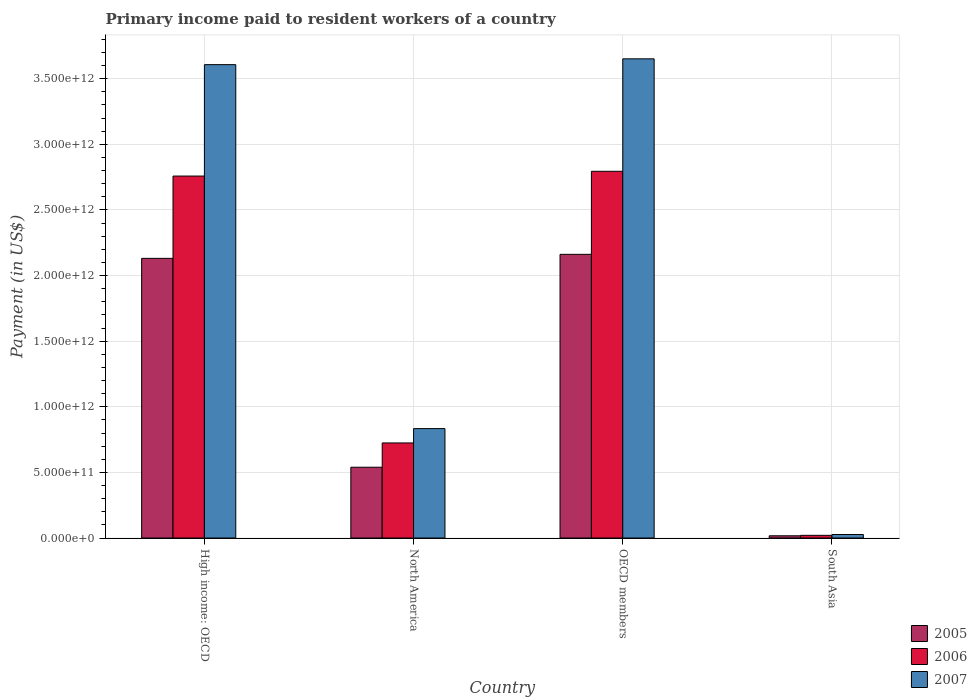How many groups of bars are there?
Your answer should be very brief. 4. Are the number of bars per tick equal to the number of legend labels?
Your answer should be very brief. Yes. How many bars are there on the 1st tick from the right?
Provide a short and direct response. 3. What is the label of the 4th group of bars from the left?
Your answer should be very brief. South Asia. In how many cases, is the number of bars for a given country not equal to the number of legend labels?
Your answer should be very brief. 0. What is the amount paid to workers in 2005 in OECD members?
Offer a very short reply. 2.16e+12. Across all countries, what is the maximum amount paid to workers in 2006?
Offer a very short reply. 2.79e+12. Across all countries, what is the minimum amount paid to workers in 2005?
Provide a short and direct response. 1.69e+1. In which country was the amount paid to workers in 2006 minimum?
Your response must be concise. South Asia. What is the total amount paid to workers in 2007 in the graph?
Offer a terse response. 8.12e+12. What is the difference between the amount paid to workers in 2005 in OECD members and that in South Asia?
Offer a terse response. 2.15e+12. What is the difference between the amount paid to workers in 2005 in OECD members and the amount paid to workers in 2007 in South Asia?
Offer a very short reply. 2.14e+12. What is the average amount paid to workers in 2007 per country?
Your response must be concise. 2.03e+12. What is the difference between the amount paid to workers of/in 2006 and amount paid to workers of/in 2005 in OECD members?
Give a very brief answer. 6.33e+11. In how many countries, is the amount paid to workers in 2006 greater than 1100000000000 US$?
Provide a short and direct response. 2. What is the ratio of the amount paid to workers in 2005 in North America to that in OECD members?
Provide a short and direct response. 0.25. Is the amount paid to workers in 2005 in High income: OECD less than that in OECD members?
Ensure brevity in your answer.  Yes. What is the difference between the highest and the second highest amount paid to workers in 2007?
Offer a terse response. 4.43e+1. What is the difference between the highest and the lowest amount paid to workers in 2006?
Provide a succinct answer. 2.77e+12. In how many countries, is the amount paid to workers in 2005 greater than the average amount paid to workers in 2005 taken over all countries?
Offer a terse response. 2. What does the 2nd bar from the left in South Asia represents?
Offer a terse response. 2006. Are all the bars in the graph horizontal?
Provide a short and direct response. No. How many countries are there in the graph?
Provide a succinct answer. 4. What is the difference between two consecutive major ticks on the Y-axis?
Give a very brief answer. 5.00e+11. Are the values on the major ticks of Y-axis written in scientific E-notation?
Provide a short and direct response. Yes. Does the graph contain any zero values?
Ensure brevity in your answer.  No. Where does the legend appear in the graph?
Make the answer very short. Bottom right. How are the legend labels stacked?
Offer a very short reply. Vertical. What is the title of the graph?
Keep it short and to the point. Primary income paid to resident workers of a country. What is the label or title of the Y-axis?
Keep it short and to the point. Payment (in US$). What is the Payment (in US$) in 2005 in High income: OECD?
Give a very brief answer. 2.13e+12. What is the Payment (in US$) in 2006 in High income: OECD?
Offer a very short reply. 2.76e+12. What is the Payment (in US$) of 2007 in High income: OECD?
Give a very brief answer. 3.61e+12. What is the Payment (in US$) of 2005 in North America?
Ensure brevity in your answer.  5.39e+11. What is the Payment (in US$) in 2006 in North America?
Your answer should be very brief. 7.24e+11. What is the Payment (in US$) in 2007 in North America?
Provide a short and direct response. 8.34e+11. What is the Payment (in US$) of 2005 in OECD members?
Your answer should be compact. 2.16e+12. What is the Payment (in US$) in 2006 in OECD members?
Your answer should be compact. 2.79e+12. What is the Payment (in US$) in 2007 in OECD members?
Provide a succinct answer. 3.65e+12. What is the Payment (in US$) in 2005 in South Asia?
Offer a very short reply. 1.69e+1. What is the Payment (in US$) in 2006 in South Asia?
Provide a succinct answer. 2.04e+1. What is the Payment (in US$) of 2007 in South Asia?
Your answer should be very brief. 2.66e+1. Across all countries, what is the maximum Payment (in US$) of 2005?
Make the answer very short. 2.16e+12. Across all countries, what is the maximum Payment (in US$) in 2006?
Give a very brief answer. 2.79e+12. Across all countries, what is the maximum Payment (in US$) of 2007?
Provide a succinct answer. 3.65e+12. Across all countries, what is the minimum Payment (in US$) of 2005?
Keep it short and to the point. 1.69e+1. Across all countries, what is the minimum Payment (in US$) in 2006?
Keep it short and to the point. 2.04e+1. Across all countries, what is the minimum Payment (in US$) of 2007?
Your answer should be very brief. 2.66e+1. What is the total Payment (in US$) in 2005 in the graph?
Ensure brevity in your answer.  4.85e+12. What is the total Payment (in US$) in 2006 in the graph?
Offer a terse response. 6.30e+12. What is the total Payment (in US$) in 2007 in the graph?
Keep it short and to the point. 8.12e+12. What is the difference between the Payment (in US$) in 2005 in High income: OECD and that in North America?
Offer a terse response. 1.59e+12. What is the difference between the Payment (in US$) of 2006 in High income: OECD and that in North America?
Offer a terse response. 2.03e+12. What is the difference between the Payment (in US$) of 2007 in High income: OECD and that in North America?
Make the answer very short. 2.77e+12. What is the difference between the Payment (in US$) of 2005 in High income: OECD and that in OECD members?
Give a very brief answer. -3.07e+1. What is the difference between the Payment (in US$) of 2006 in High income: OECD and that in OECD members?
Provide a succinct answer. -3.64e+1. What is the difference between the Payment (in US$) in 2007 in High income: OECD and that in OECD members?
Offer a very short reply. -4.43e+1. What is the difference between the Payment (in US$) in 2005 in High income: OECD and that in South Asia?
Give a very brief answer. 2.11e+12. What is the difference between the Payment (in US$) in 2006 in High income: OECD and that in South Asia?
Make the answer very short. 2.74e+12. What is the difference between the Payment (in US$) of 2007 in High income: OECD and that in South Asia?
Keep it short and to the point. 3.58e+12. What is the difference between the Payment (in US$) in 2005 in North America and that in OECD members?
Your answer should be compact. -1.62e+12. What is the difference between the Payment (in US$) in 2006 in North America and that in OECD members?
Your answer should be very brief. -2.07e+12. What is the difference between the Payment (in US$) in 2007 in North America and that in OECD members?
Your response must be concise. -2.82e+12. What is the difference between the Payment (in US$) of 2005 in North America and that in South Asia?
Provide a succinct answer. 5.23e+11. What is the difference between the Payment (in US$) of 2006 in North America and that in South Asia?
Keep it short and to the point. 7.04e+11. What is the difference between the Payment (in US$) in 2007 in North America and that in South Asia?
Provide a succinct answer. 8.07e+11. What is the difference between the Payment (in US$) in 2005 in OECD members and that in South Asia?
Your answer should be compact. 2.15e+12. What is the difference between the Payment (in US$) in 2006 in OECD members and that in South Asia?
Provide a succinct answer. 2.77e+12. What is the difference between the Payment (in US$) in 2007 in OECD members and that in South Asia?
Your response must be concise. 3.63e+12. What is the difference between the Payment (in US$) in 2005 in High income: OECD and the Payment (in US$) in 2006 in North America?
Offer a very short reply. 1.41e+12. What is the difference between the Payment (in US$) in 2005 in High income: OECD and the Payment (in US$) in 2007 in North America?
Provide a succinct answer. 1.30e+12. What is the difference between the Payment (in US$) in 2006 in High income: OECD and the Payment (in US$) in 2007 in North America?
Keep it short and to the point. 1.92e+12. What is the difference between the Payment (in US$) in 2005 in High income: OECD and the Payment (in US$) in 2006 in OECD members?
Offer a terse response. -6.64e+11. What is the difference between the Payment (in US$) in 2005 in High income: OECD and the Payment (in US$) in 2007 in OECD members?
Give a very brief answer. -1.52e+12. What is the difference between the Payment (in US$) in 2006 in High income: OECD and the Payment (in US$) in 2007 in OECD members?
Your answer should be compact. -8.93e+11. What is the difference between the Payment (in US$) in 2005 in High income: OECD and the Payment (in US$) in 2006 in South Asia?
Offer a terse response. 2.11e+12. What is the difference between the Payment (in US$) of 2005 in High income: OECD and the Payment (in US$) of 2007 in South Asia?
Keep it short and to the point. 2.10e+12. What is the difference between the Payment (in US$) of 2006 in High income: OECD and the Payment (in US$) of 2007 in South Asia?
Provide a short and direct response. 2.73e+12. What is the difference between the Payment (in US$) of 2005 in North America and the Payment (in US$) of 2006 in OECD members?
Provide a succinct answer. -2.26e+12. What is the difference between the Payment (in US$) in 2005 in North America and the Payment (in US$) in 2007 in OECD members?
Offer a terse response. -3.11e+12. What is the difference between the Payment (in US$) of 2006 in North America and the Payment (in US$) of 2007 in OECD members?
Make the answer very short. -2.93e+12. What is the difference between the Payment (in US$) of 2005 in North America and the Payment (in US$) of 2006 in South Asia?
Give a very brief answer. 5.19e+11. What is the difference between the Payment (in US$) in 2005 in North America and the Payment (in US$) in 2007 in South Asia?
Offer a terse response. 5.13e+11. What is the difference between the Payment (in US$) of 2006 in North America and the Payment (in US$) of 2007 in South Asia?
Your answer should be very brief. 6.98e+11. What is the difference between the Payment (in US$) in 2005 in OECD members and the Payment (in US$) in 2006 in South Asia?
Offer a terse response. 2.14e+12. What is the difference between the Payment (in US$) of 2005 in OECD members and the Payment (in US$) of 2007 in South Asia?
Your response must be concise. 2.14e+12. What is the difference between the Payment (in US$) of 2006 in OECD members and the Payment (in US$) of 2007 in South Asia?
Make the answer very short. 2.77e+12. What is the average Payment (in US$) of 2005 per country?
Your answer should be very brief. 1.21e+12. What is the average Payment (in US$) of 2006 per country?
Your answer should be compact. 1.57e+12. What is the average Payment (in US$) of 2007 per country?
Your response must be concise. 2.03e+12. What is the difference between the Payment (in US$) of 2005 and Payment (in US$) of 2006 in High income: OECD?
Your response must be concise. -6.27e+11. What is the difference between the Payment (in US$) in 2005 and Payment (in US$) in 2007 in High income: OECD?
Keep it short and to the point. -1.48e+12. What is the difference between the Payment (in US$) of 2006 and Payment (in US$) of 2007 in High income: OECD?
Offer a terse response. -8.49e+11. What is the difference between the Payment (in US$) in 2005 and Payment (in US$) in 2006 in North America?
Keep it short and to the point. -1.85e+11. What is the difference between the Payment (in US$) of 2005 and Payment (in US$) of 2007 in North America?
Offer a very short reply. -2.94e+11. What is the difference between the Payment (in US$) in 2006 and Payment (in US$) in 2007 in North America?
Provide a succinct answer. -1.09e+11. What is the difference between the Payment (in US$) of 2005 and Payment (in US$) of 2006 in OECD members?
Make the answer very short. -6.33e+11. What is the difference between the Payment (in US$) in 2005 and Payment (in US$) in 2007 in OECD members?
Your answer should be very brief. -1.49e+12. What is the difference between the Payment (in US$) of 2006 and Payment (in US$) of 2007 in OECD members?
Ensure brevity in your answer.  -8.57e+11. What is the difference between the Payment (in US$) of 2005 and Payment (in US$) of 2006 in South Asia?
Your answer should be very brief. -3.46e+09. What is the difference between the Payment (in US$) in 2005 and Payment (in US$) in 2007 in South Asia?
Your answer should be compact. -9.75e+09. What is the difference between the Payment (in US$) in 2006 and Payment (in US$) in 2007 in South Asia?
Offer a terse response. -6.29e+09. What is the ratio of the Payment (in US$) of 2005 in High income: OECD to that in North America?
Offer a very short reply. 3.95. What is the ratio of the Payment (in US$) of 2006 in High income: OECD to that in North America?
Provide a succinct answer. 3.81. What is the ratio of the Payment (in US$) in 2007 in High income: OECD to that in North America?
Provide a succinct answer. 4.33. What is the ratio of the Payment (in US$) in 2005 in High income: OECD to that in OECD members?
Give a very brief answer. 0.99. What is the ratio of the Payment (in US$) of 2007 in High income: OECD to that in OECD members?
Make the answer very short. 0.99. What is the ratio of the Payment (in US$) in 2005 in High income: OECD to that in South Asia?
Keep it short and to the point. 126.18. What is the ratio of the Payment (in US$) of 2006 in High income: OECD to that in South Asia?
Make the answer very short. 135.54. What is the ratio of the Payment (in US$) of 2007 in High income: OECD to that in South Asia?
Provide a succinct answer. 135.4. What is the ratio of the Payment (in US$) in 2005 in North America to that in OECD members?
Ensure brevity in your answer.  0.25. What is the ratio of the Payment (in US$) of 2006 in North America to that in OECD members?
Your answer should be very brief. 0.26. What is the ratio of the Payment (in US$) in 2007 in North America to that in OECD members?
Ensure brevity in your answer.  0.23. What is the ratio of the Payment (in US$) of 2005 in North America to that in South Asia?
Offer a terse response. 31.94. What is the ratio of the Payment (in US$) of 2006 in North America to that in South Asia?
Ensure brevity in your answer.  35.6. What is the ratio of the Payment (in US$) in 2007 in North America to that in South Asia?
Ensure brevity in your answer.  31.3. What is the ratio of the Payment (in US$) of 2005 in OECD members to that in South Asia?
Ensure brevity in your answer.  127.99. What is the ratio of the Payment (in US$) of 2006 in OECD members to that in South Asia?
Provide a succinct answer. 137.33. What is the ratio of the Payment (in US$) in 2007 in OECD members to that in South Asia?
Give a very brief answer. 137.06. What is the difference between the highest and the second highest Payment (in US$) in 2005?
Your answer should be compact. 3.07e+1. What is the difference between the highest and the second highest Payment (in US$) of 2006?
Give a very brief answer. 3.64e+1. What is the difference between the highest and the second highest Payment (in US$) of 2007?
Provide a short and direct response. 4.43e+1. What is the difference between the highest and the lowest Payment (in US$) of 2005?
Your answer should be very brief. 2.15e+12. What is the difference between the highest and the lowest Payment (in US$) in 2006?
Offer a very short reply. 2.77e+12. What is the difference between the highest and the lowest Payment (in US$) in 2007?
Provide a short and direct response. 3.63e+12. 